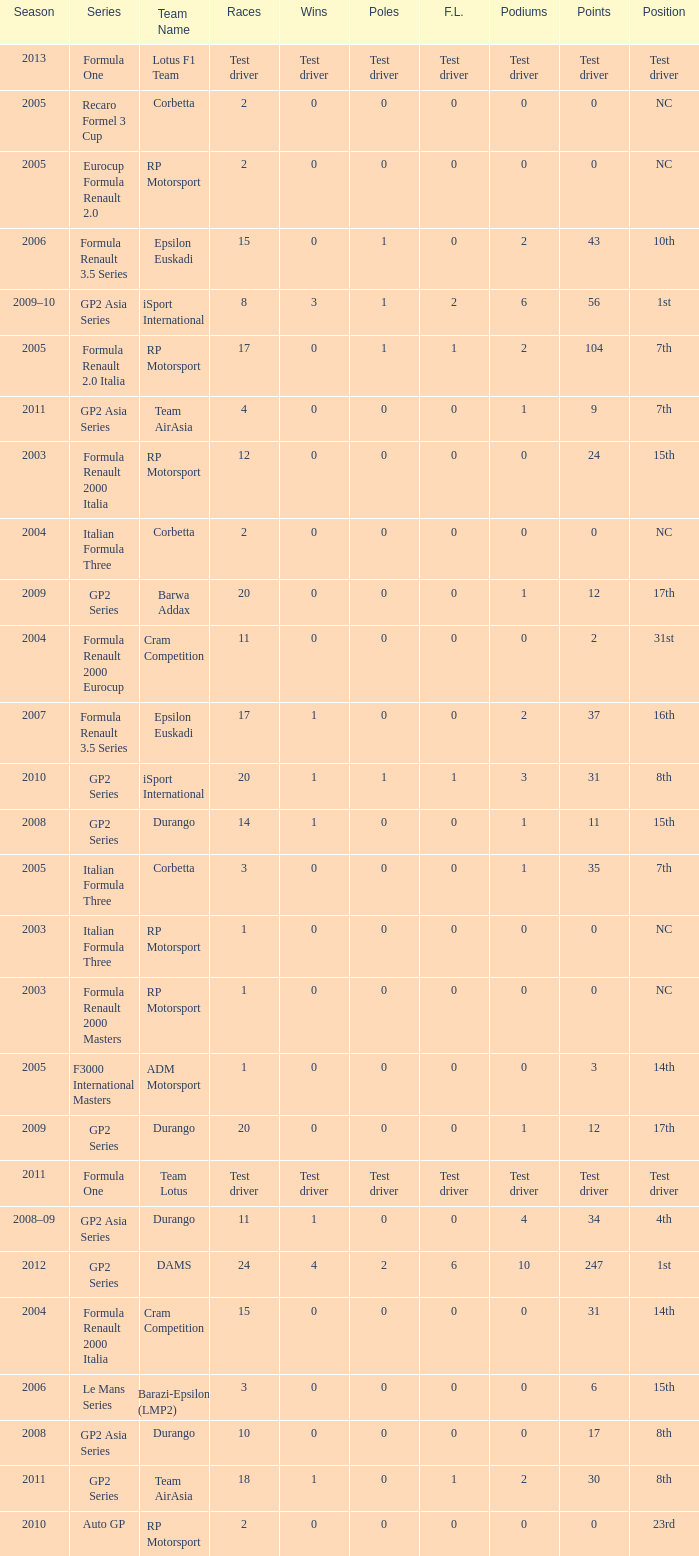What races have gp2 series, 0 F.L. and a 17th position? 20, 20. 